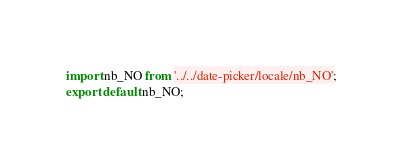<code> <loc_0><loc_0><loc_500><loc_500><_TypeScript_>import nb_NO from '../../date-picker/locale/nb_NO';
export default nb_NO;
</code> 